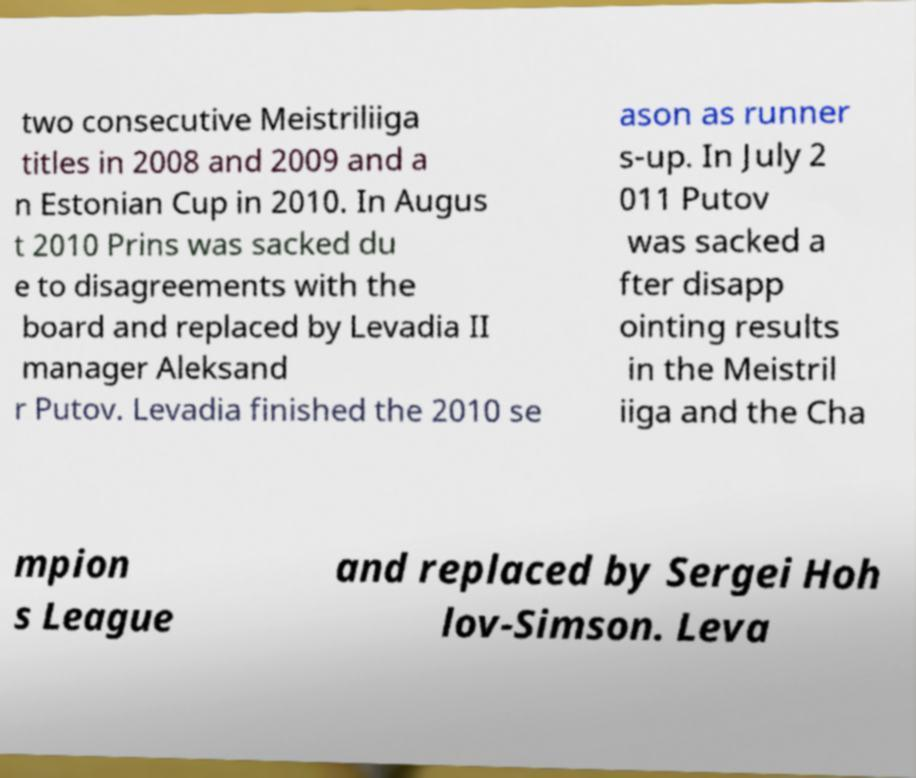I need the written content from this picture converted into text. Can you do that? two consecutive Meistriliiga titles in 2008 and 2009 and a n Estonian Cup in 2010. In Augus t 2010 Prins was sacked du e to disagreements with the board and replaced by Levadia II manager Aleksand r Putov. Levadia finished the 2010 se ason as runner s-up. In July 2 011 Putov was sacked a fter disapp ointing results in the Meistril iiga and the Cha mpion s League and replaced by Sergei Hoh lov-Simson. Leva 